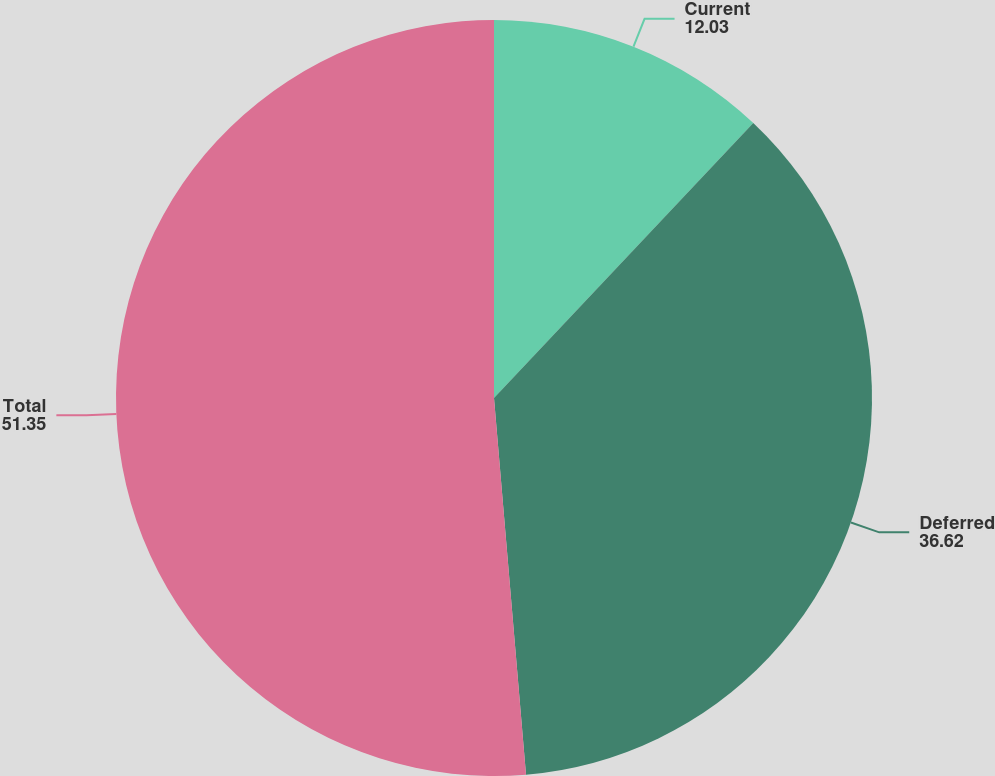<chart> <loc_0><loc_0><loc_500><loc_500><pie_chart><fcel>Current<fcel>Deferred<fcel>Total<nl><fcel>12.03%<fcel>36.62%<fcel>51.35%<nl></chart> 